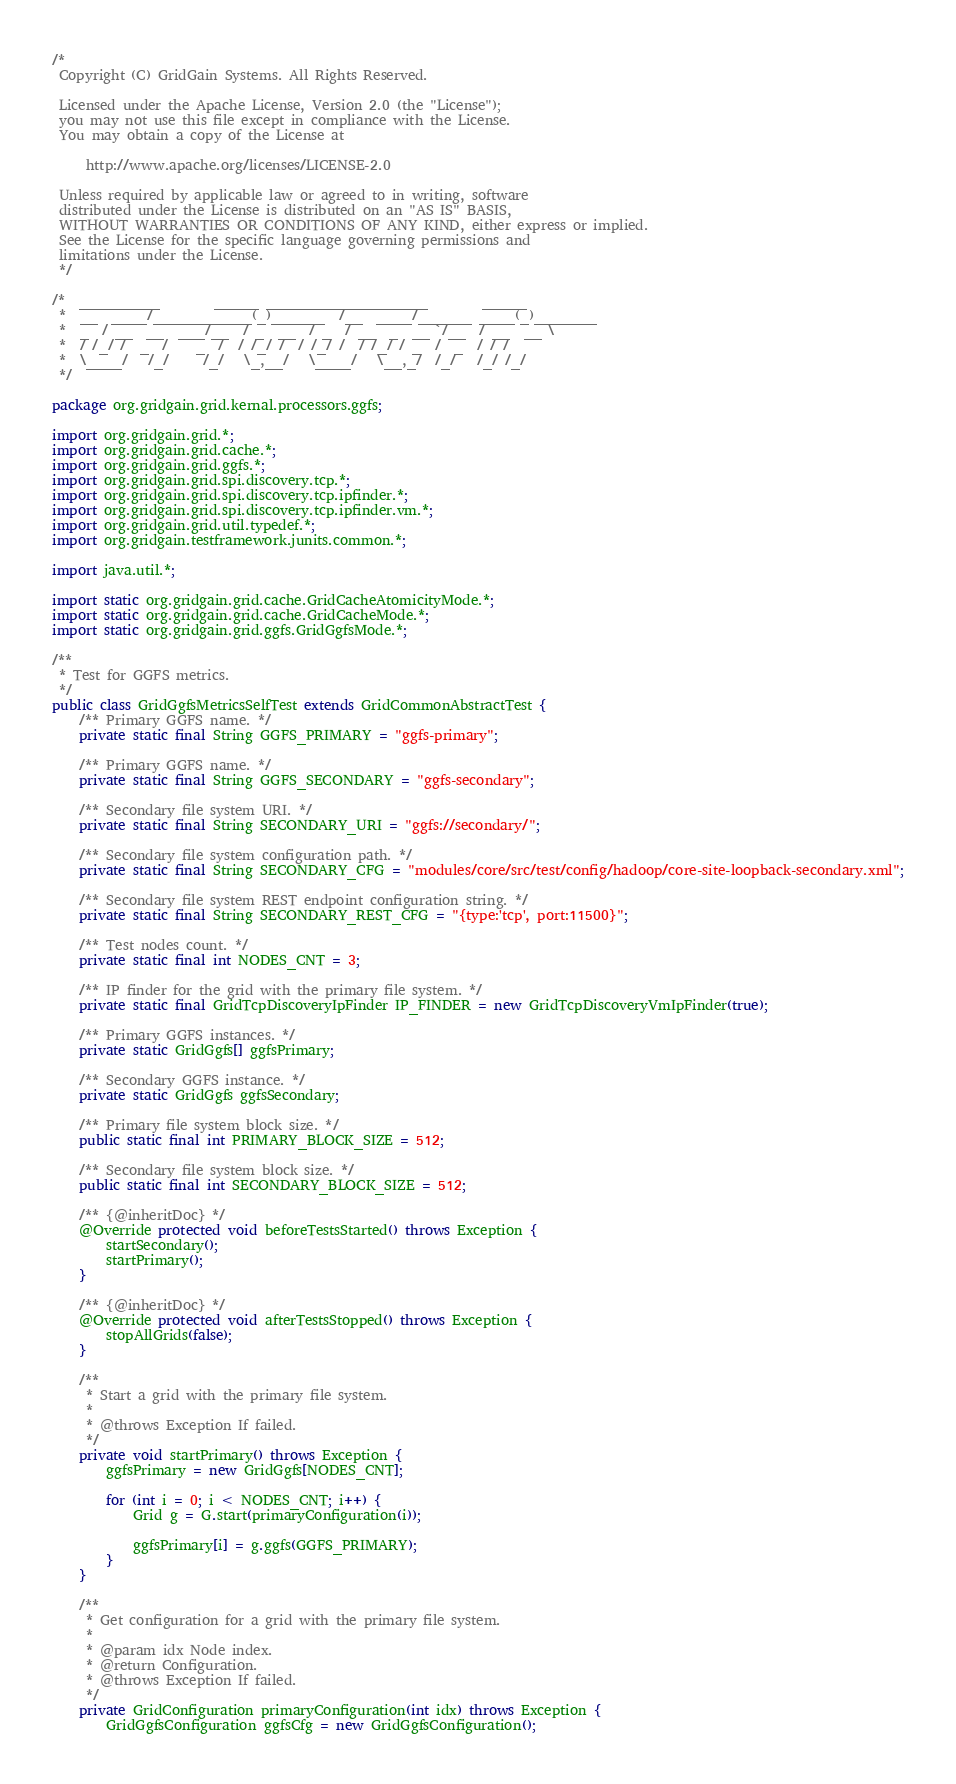<code> <loc_0><loc_0><loc_500><loc_500><_Java_>/* 
 Copyright (C) GridGain Systems. All Rights Reserved.
 
 Licensed under the Apache License, Version 2.0 (the "License");
 you may not use this file except in compliance with the License.
 You may obtain a copy of the License at

     http://www.apache.org/licenses/LICENSE-2.0
 
 Unless required by applicable law or agreed to in writing, software
 distributed under the License is distributed on an "AS IS" BASIS,
 WITHOUT WARRANTIES OR CONDITIONS OF ANY KIND, either express or implied.
 See the License for the specific language governing permissions and
 limitations under the License.
 */

/*  _________        _____ __________________        _____
 *  __  ____/___________(_)______  /__  ____/______ ____(_)_______
 *  _  / __  __  ___/__  / _  __  / _  / __  _  __ `/__  / __  __ \
 *  / /_/ /  _  /    _  /  / /_/ /  / /_/ /  / /_/ / _  /  _  / / /
 *  \____/   /_/     /_/   \_,__/   \____/   \__,_/  /_/   /_/ /_/
 */

package org.gridgain.grid.kernal.processors.ggfs;

import org.gridgain.grid.*;
import org.gridgain.grid.cache.*;
import org.gridgain.grid.ggfs.*;
import org.gridgain.grid.spi.discovery.tcp.*;
import org.gridgain.grid.spi.discovery.tcp.ipfinder.*;
import org.gridgain.grid.spi.discovery.tcp.ipfinder.vm.*;
import org.gridgain.grid.util.typedef.*;
import org.gridgain.testframework.junits.common.*;

import java.util.*;

import static org.gridgain.grid.cache.GridCacheAtomicityMode.*;
import static org.gridgain.grid.cache.GridCacheMode.*;
import static org.gridgain.grid.ggfs.GridGgfsMode.*;

/**
 * Test for GGFS metrics.
 */
public class GridGgfsMetricsSelfTest extends GridCommonAbstractTest {
    /** Primary GGFS name. */
    private static final String GGFS_PRIMARY = "ggfs-primary";

    /** Primary GGFS name. */
    private static final String GGFS_SECONDARY = "ggfs-secondary";

    /** Secondary file system URI. */
    private static final String SECONDARY_URI = "ggfs://secondary/";

    /** Secondary file system configuration path. */
    private static final String SECONDARY_CFG = "modules/core/src/test/config/hadoop/core-site-loopback-secondary.xml";

    /** Secondary file system REST endpoint configuration string. */
    private static final String SECONDARY_REST_CFG = "{type:'tcp', port:11500}";

    /** Test nodes count. */
    private static final int NODES_CNT = 3;

    /** IP finder for the grid with the primary file system. */
    private static final GridTcpDiscoveryIpFinder IP_FINDER = new GridTcpDiscoveryVmIpFinder(true);

    /** Primary GGFS instances. */
    private static GridGgfs[] ggfsPrimary;

    /** Secondary GGFS instance. */
    private static GridGgfs ggfsSecondary;

    /** Primary file system block size. */
    public static final int PRIMARY_BLOCK_SIZE = 512;

    /** Secondary file system block size. */
    public static final int SECONDARY_BLOCK_SIZE = 512;

    /** {@inheritDoc} */
    @Override protected void beforeTestsStarted() throws Exception {
        startSecondary();
        startPrimary();
    }

    /** {@inheritDoc} */
    @Override protected void afterTestsStopped() throws Exception {
        stopAllGrids(false);
    }

    /**
     * Start a grid with the primary file system.
     *
     * @throws Exception If failed.
     */
    private void startPrimary() throws Exception {
        ggfsPrimary = new GridGgfs[NODES_CNT];

        for (int i = 0; i < NODES_CNT; i++) {
            Grid g = G.start(primaryConfiguration(i));

            ggfsPrimary[i] = g.ggfs(GGFS_PRIMARY);
        }
    }

    /**
     * Get configuration for a grid with the primary file system.
     *
     * @param idx Node index.
     * @return Configuration.
     * @throws Exception If failed.
     */
    private GridConfiguration primaryConfiguration(int idx) throws Exception {
        GridGgfsConfiguration ggfsCfg = new GridGgfsConfiguration();
</code> 